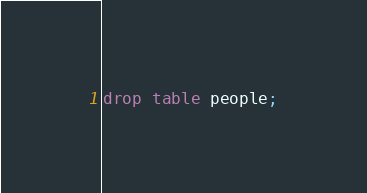<code> <loc_0><loc_0><loc_500><loc_500><_SQL_>drop table people;</code> 